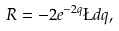<formula> <loc_0><loc_0><loc_500><loc_500>R = - 2 e ^ { - 2 q } \L d q ,</formula> 